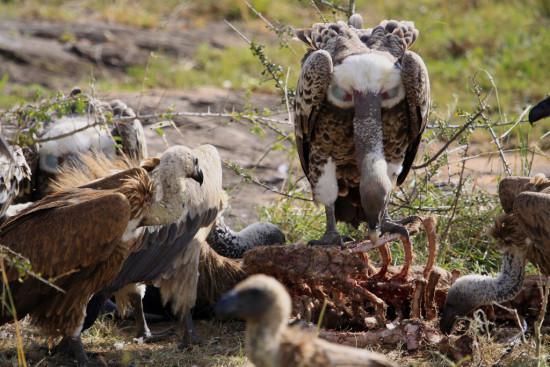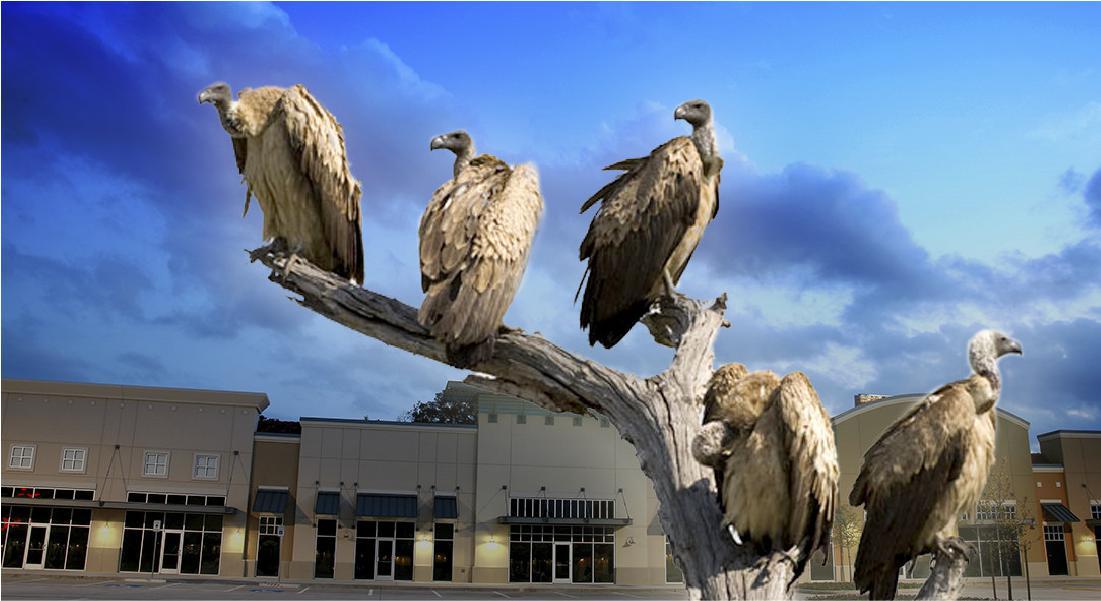The first image is the image on the left, the second image is the image on the right. For the images displayed, is the sentence "Three or more vultures perched on a branch are visible." factually correct? Answer yes or no. Yes. 